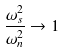<formula> <loc_0><loc_0><loc_500><loc_500>\frac { \omega _ { s } ^ { 2 } } { \omega _ { n } ^ { 2 } } \rightarrow 1</formula> 